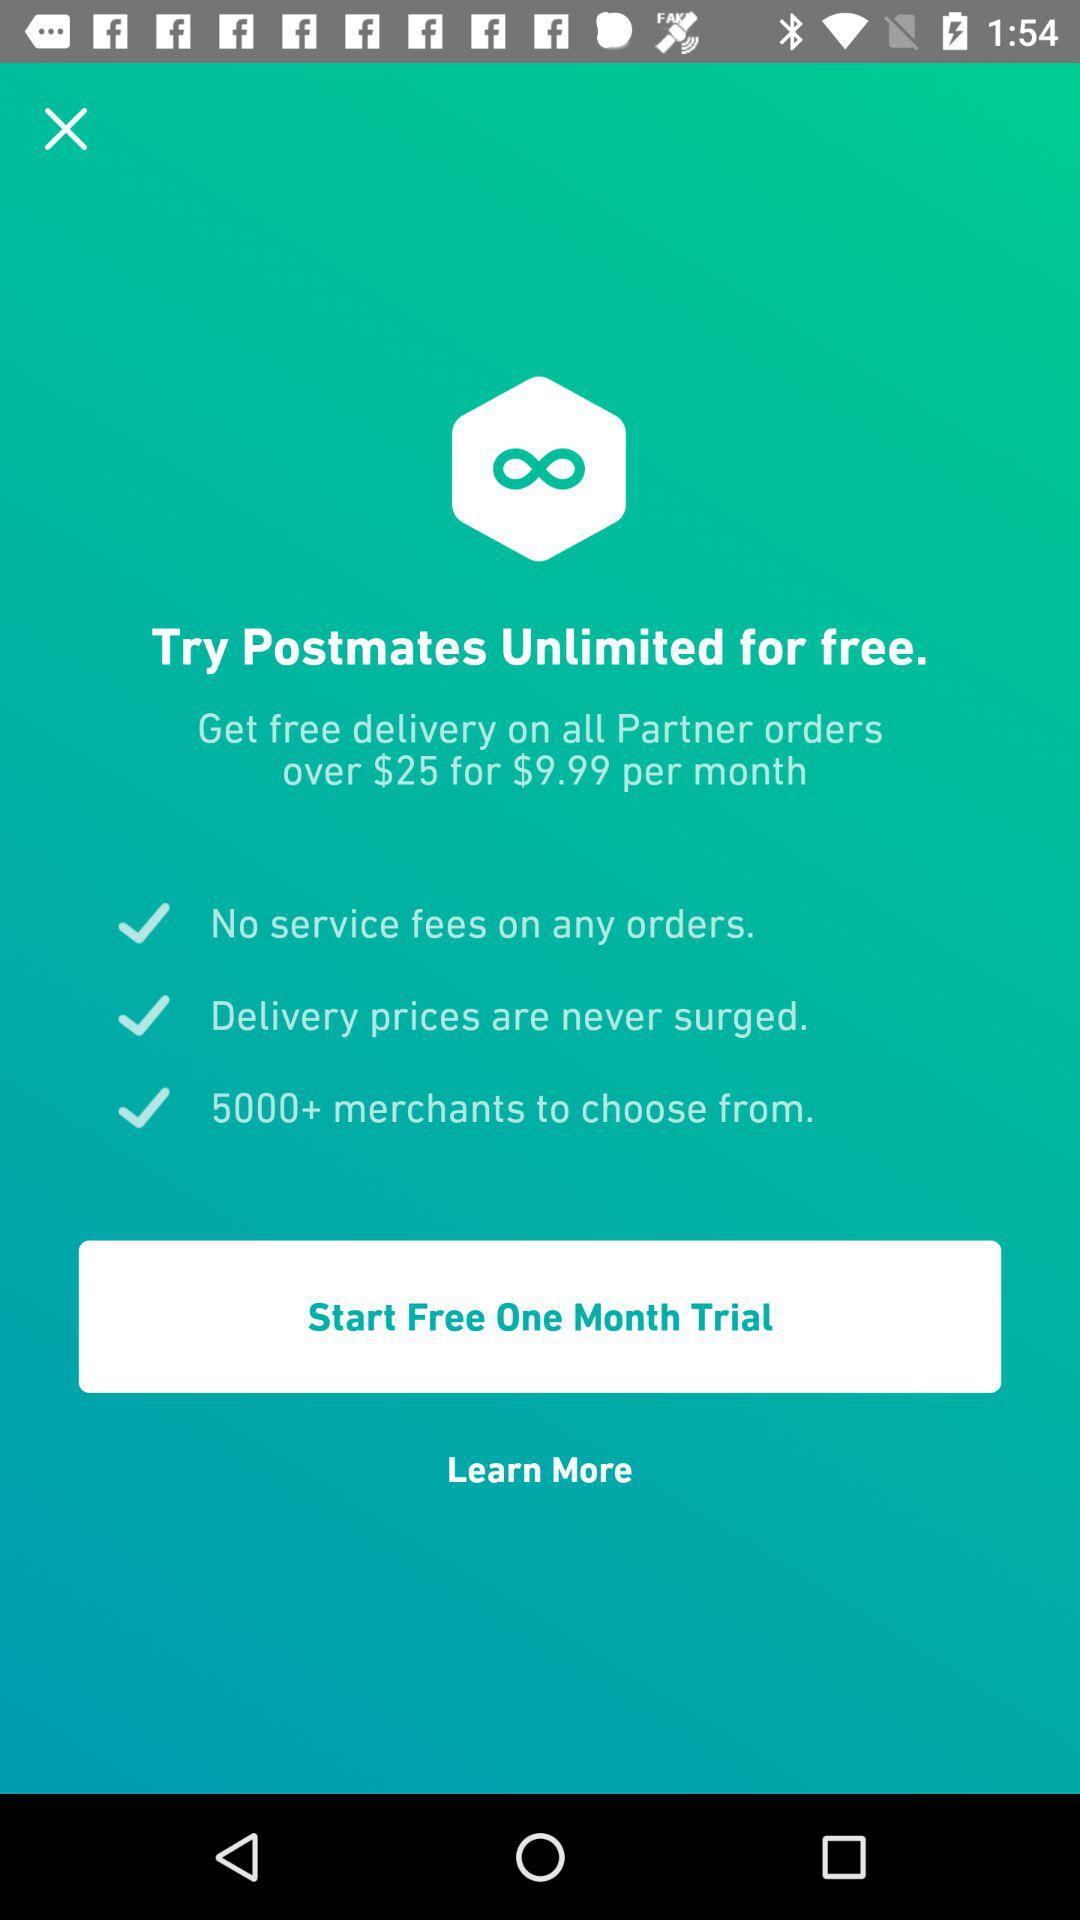What is the duration of the free trial? The duration of the free trial is "One Month". 